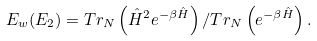Convert formula to latex. <formula><loc_0><loc_0><loc_500><loc_500>E _ { w } ( E _ { 2 } ) = T r _ { N } \left ( \hat { H } ^ { 2 } e ^ { - \beta \hat { H } } \right ) / T r _ { N } \left ( e ^ { - \beta \hat { H } } \right ) .</formula> 